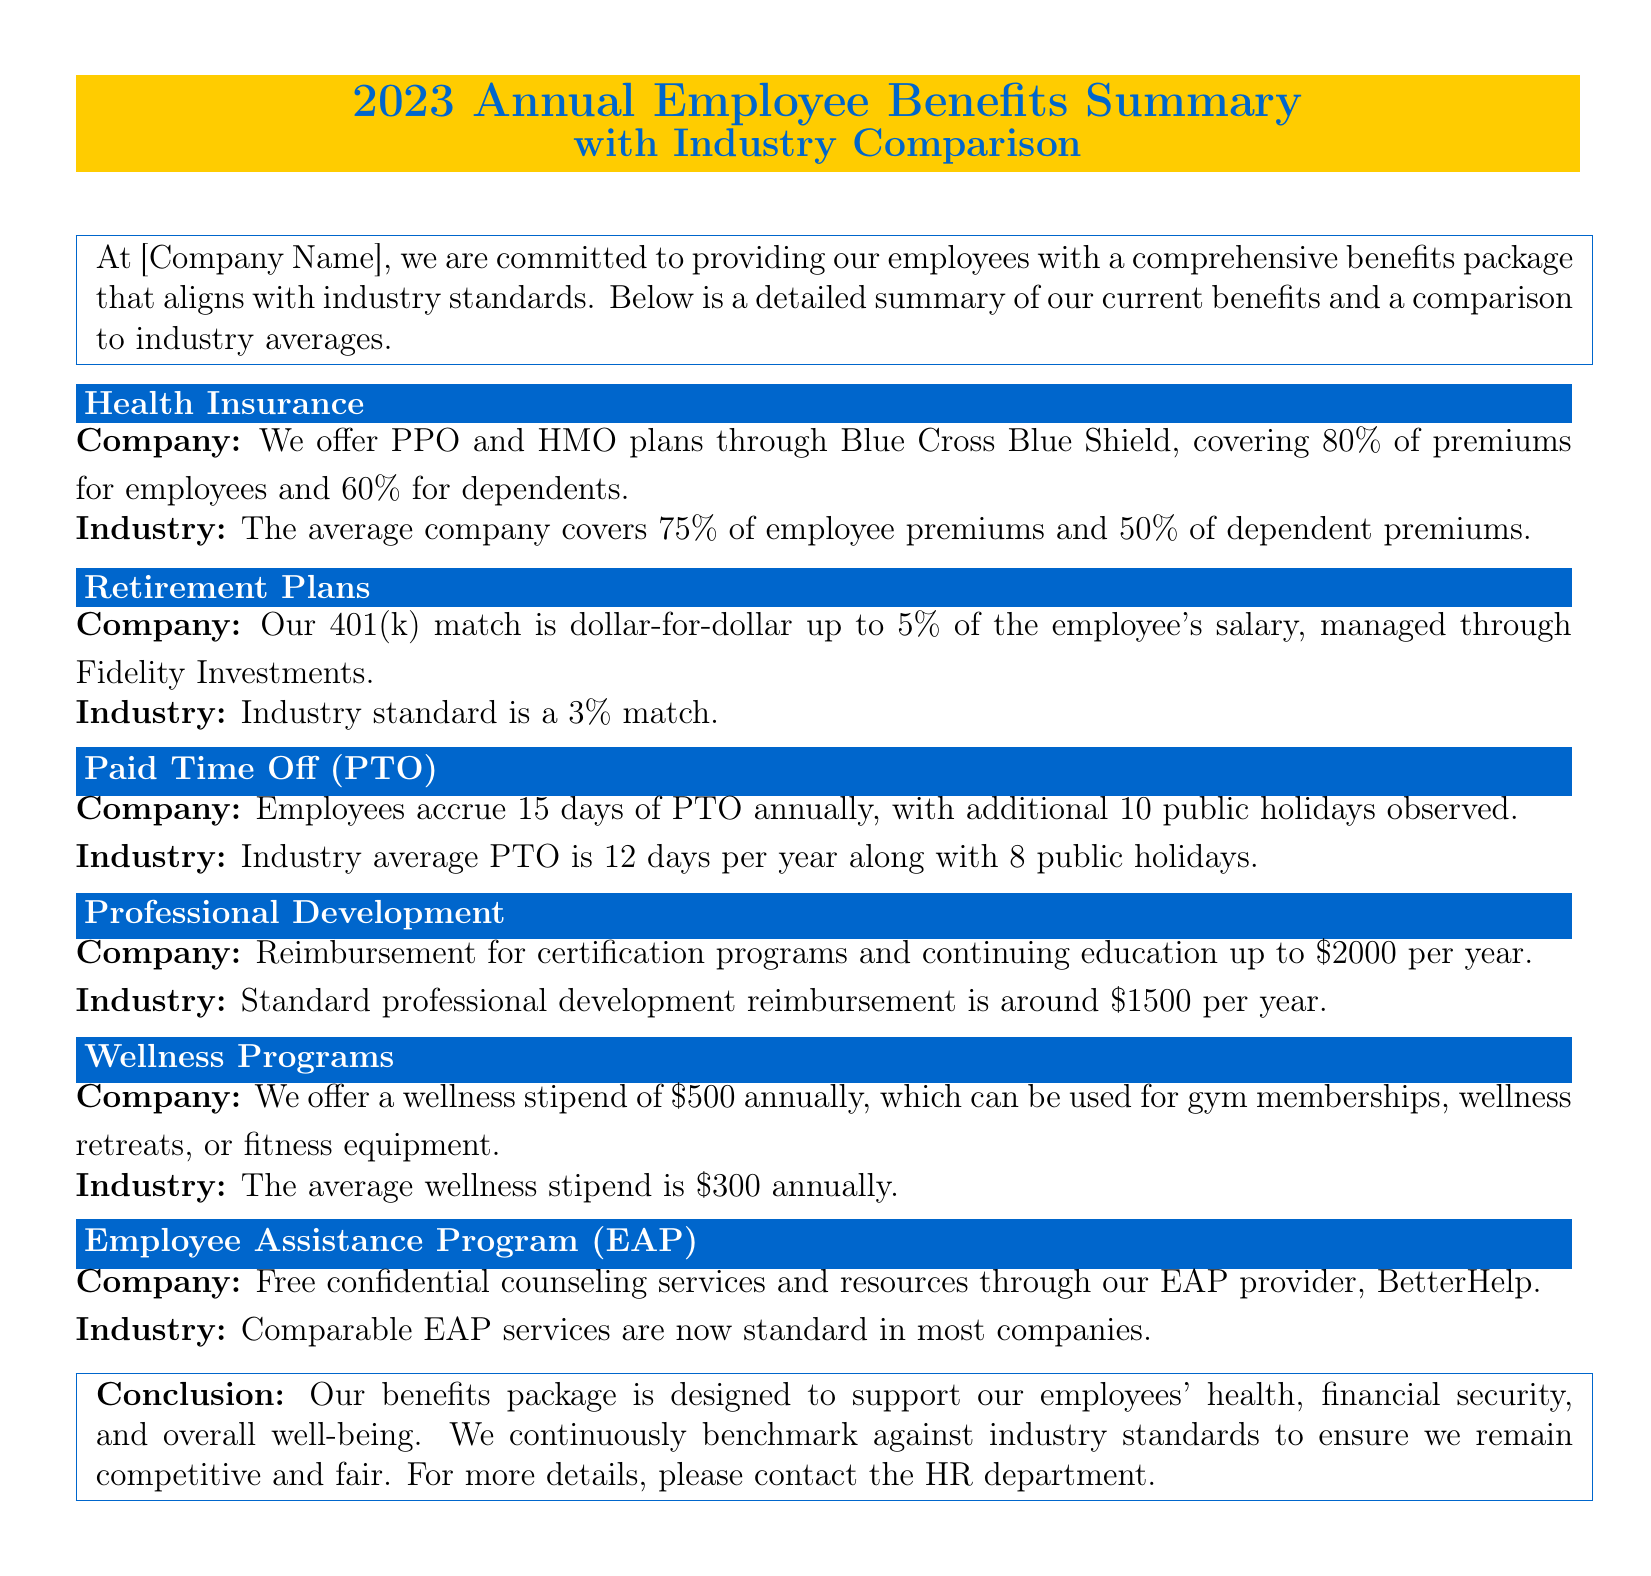What percentage of premiums does the company cover for employees? The document states that the company covers 80% of premiums for employees.
Answer: 80% What is the company’s match for the 401(k) plan? The document indicates that the company matches dollar-for-dollar up to 5% of the employee's salary.
Answer: Dollar-for-dollar up to 5% How many days of PTO do employees accrue annually? According to the document, employees accrue 15 days of PTO annually.
Answer: 15 days What is the average annual wellness stipend in the industry? The document notes that the average wellness stipend in the industry is $300 annually.
Answer: $300 Which company is mentioned for managing the retirement plans? The document states that Fidelity Investments manages the 401(k) matching plan.
Answer: Fidelity Investments What is the reimbursement limit for professional development? The document specifies a reimbursement limit of $2000 per year for certification programs and continuing education.
Answer: $2000 How does the company's PTO compare to the industry average? The document explains that the company's PTO of 15 days exceeds the industry average of 12 days.
Answer: Exceeds What service does the company’s EAP provider offer? The document mentions free confidential counseling services through the EAP provider, BetterHelp.
Answer: Counseling services What is the industry standard for professional development reimbursement? The document states that the standard professional development reimbursement is around $1500 per year.
Answer: $1500 